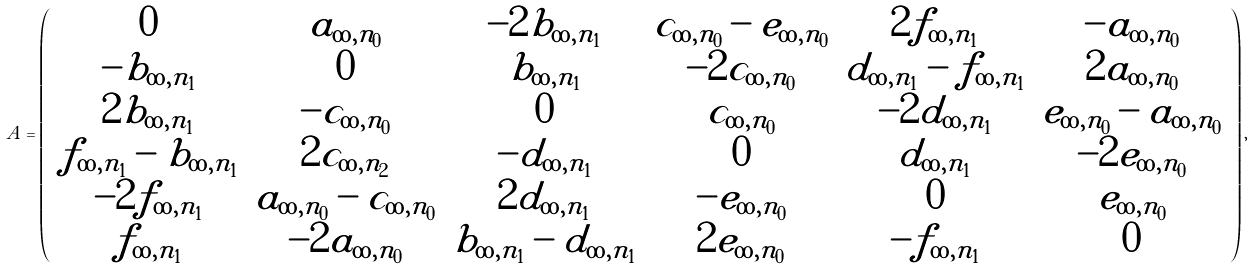Convert formula to latex. <formula><loc_0><loc_0><loc_500><loc_500>A = \left ( \begin{array} { c c c c c c } 0 & a _ { \infty , n _ { 0 } } & - 2 b _ { \infty , n _ { 1 } } & c _ { \infty , n _ { 0 } } - e _ { \infty , n _ { 0 } } & 2 f _ { \infty , n _ { 1 } } & - a _ { \infty , n _ { 0 } } \\ - b _ { \infty , n _ { 1 } } & 0 & b _ { \infty , n _ { 1 } } & - 2 c _ { \infty , n _ { 0 } } & d _ { \infty , n _ { 1 } } - f _ { \infty , n _ { 1 } } & 2 a _ { \infty , n _ { 0 } } \\ 2 b _ { \infty , n _ { 1 } } & - c _ { \infty , n _ { 0 } } & 0 & c _ { \infty , n _ { 0 } } & - 2 d _ { \infty , n _ { 1 } } & e _ { \infty , n _ { 0 } } - a _ { \infty , n _ { 0 } } \\ f _ { \infty , n _ { 1 } } - b _ { \infty , n _ { 1 } } & 2 c _ { \infty , n _ { 2 } } & - d _ { \infty , n _ { 1 } } & 0 & d _ { \infty , n _ { 1 } } & - 2 e _ { \infty , n _ { 0 } } \\ - 2 f _ { \infty , n _ { 1 } } & a _ { \infty , n _ { 0 } } - c _ { \infty , n _ { 0 } } & 2 d _ { \infty , n _ { 1 } } & - e _ { \infty , n _ { 0 } } & 0 & e _ { \infty , n _ { 0 } } \\ f _ { \infty , n _ { 1 } } & - 2 a _ { \infty , n _ { 0 } } & b _ { \infty , n _ { 1 } } - d _ { \infty , n _ { 1 } } & 2 e _ { \infty , n _ { 0 } } & - f _ { \infty , n _ { 1 } } & 0 \\ \end{array} \right ) ,</formula> 